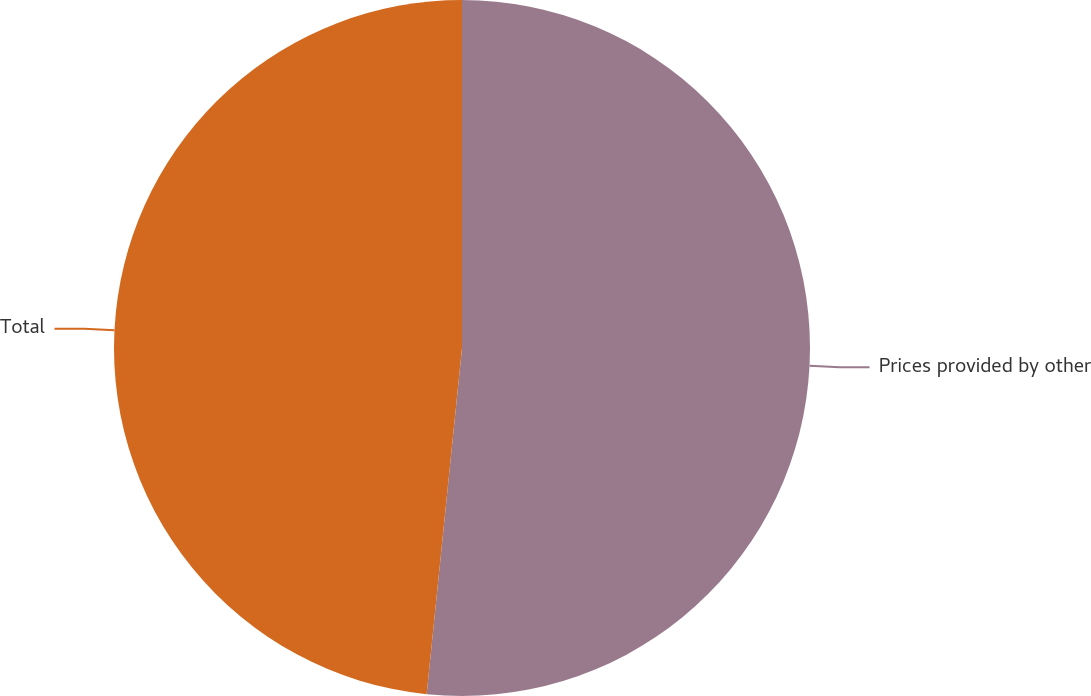Convert chart. <chart><loc_0><loc_0><loc_500><loc_500><pie_chart><fcel>Prices provided by other<fcel>Total<nl><fcel>51.62%<fcel>48.38%<nl></chart> 